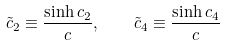Convert formula to latex. <formula><loc_0><loc_0><loc_500><loc_500>\tilde { c } _ { 2 } \equiv \frac { \sinh c _ { 2 } } { c } , \quad \tilde { c } _ { 4 } \equiv \frac { \sinh c _ { 4 } } { c }</formula> 